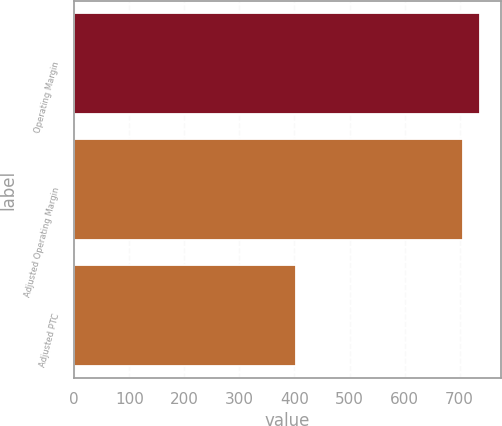Convert chart to OTSL. <chart><loc_0><loc_0><loc_500><loc_500><bar_chart><fcel>Operating Margin<fcel>Adjusted Operating Margin<fcel>Adjusted PTC<nl><fcel>737.8<fcel>707<fcel>403<nl></chart> 